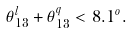Convert formula to latex. <formula><loc_0><loc_0><loc_500><loc_500>\theta _ { 1 3 } ^ { l } + \theta _ { 1 3 } ^ { q } < 8 . 1 ^ { o } .</formula> 